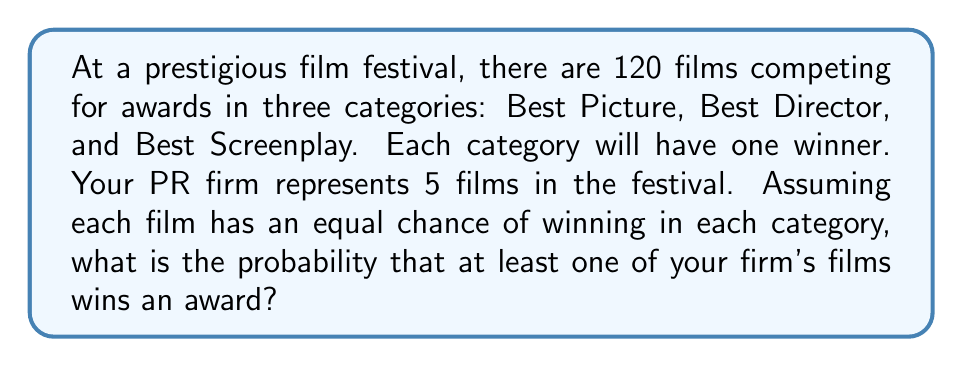What is the answer to this math problem? Let's approach this step-by-step:

1) First, let's calculate the probability of one of our films winning in a single category:
   $P(\text{winning one category}) = \frac{5}{120} = \frac{1}{24}$

2) Now, let's calculate the probability of not winning in a single category:
   $P(\text{not winning one category}) = 1 - \frac{1}{24} = \frac{23}{24}$

3) For all three categories, the probability of not winning any award is:
   $P(\text{not winning any award}) = (\frac{23}{24})^3 = \frac{12167}{13824}$

4) Therefore, the probability of winning at least one award is the opposite of not winning any:
   $P(\text{winning at least one award}) = 1 - P(\text{not winning any award})$
   $= 1 - \frac{12167}{13824} = \frac{13824 - 12167}{13824} = \frac{1657}{13824}$

5) To simplify this fraction:
   $\frac{1657}{13824} \approx 0.1198$ or about $11.98\%$

This result means that there's approximately a 12% chance that at least one of your firm's films will win an award at the festival.
Answer: $$\frac{1657}{13824} \approx 0.1198 \text{ or } 11.98\%$$ 